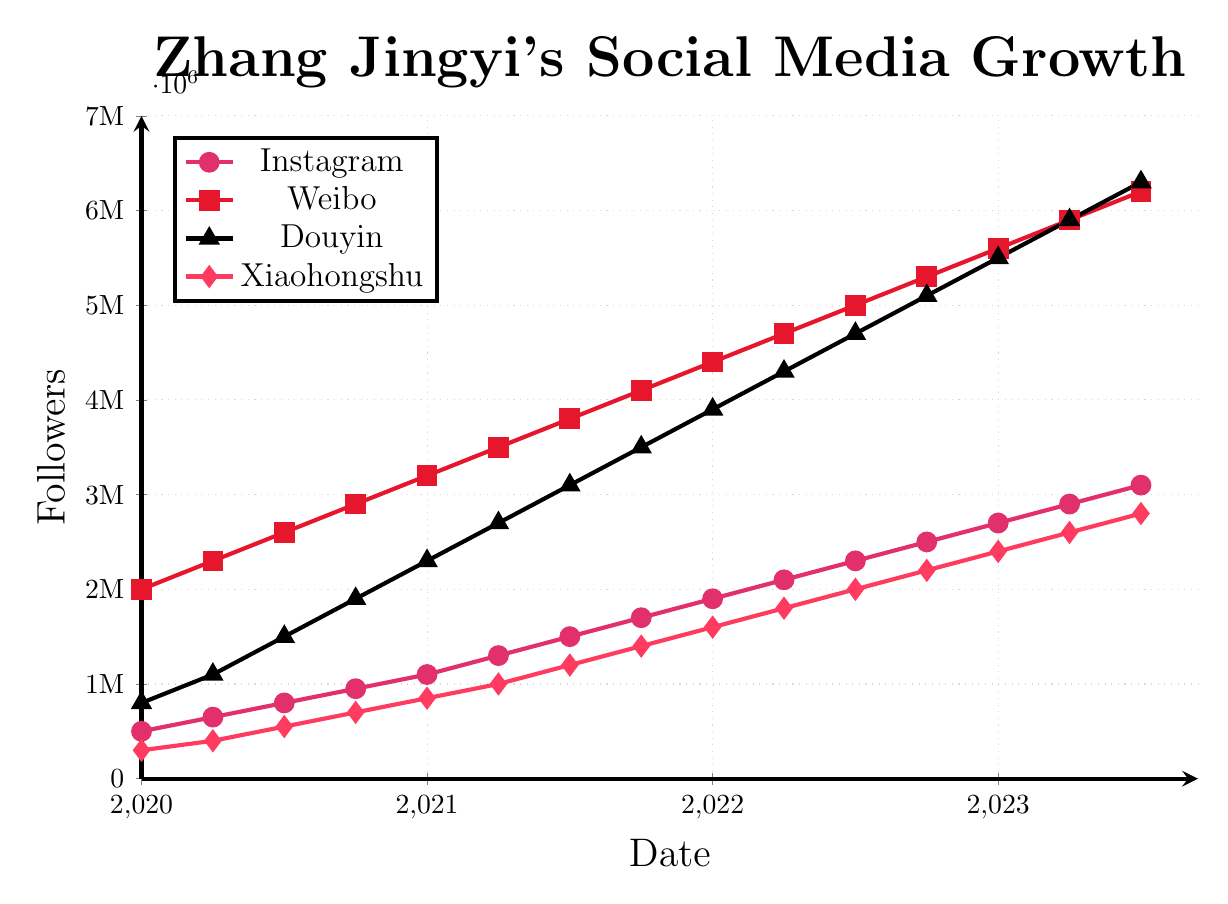Which social media platform had the highest follower count in July 2023? To determine the platform with the highest follower count in July 2023, observe the data points for each platform at the 2023.5 mark. Douyin has 6,300,000 followers, which is higher than the follower counts of Instagram, Weibo, and Xiaohongshu for that time.
Answer: Douyin How many followers did Zhang Jingyi gain on Weibo from January 2020 to July 2023? Calculate the difference between the follower count on Weibo in July 2023 and January 2020. The follower count on Weibo in July 2023 is 6,200,000, and in January 2020 it was 2,000,000. The difference is 6,200,000 - 2,000,000 = 4,200,000.
Answer: 4,200,000 Which platform showed the fastest growth from January 2020 to July 2023? Calculate the growth for each platform from January 2020 to July 2023 by subtracting the follower count at the start from the count at the end. Compare the growth values: Instagram (3,100,000 - 500,000 = 2,600,000), Weibo (6,200,000 - 2,000,000 = 4,200,000), Douyin (6,300,000 - 800,000 = 5,500,000), Xiaohongshu (2,800,000 - 300,000 = 2,500,000). Douyin has the highest increase.
Answer: Douyin What is the trend in follower growth for Xiaohongshu between mid-2020 and mid-2021? Look at the data points for Xiaohongshu between mid-2020 and mid-2021. In July 2020, it had 550,000 followers, and by July 2021, it had 1,200,000 followers. The followers steadily increased within this period, indicating a positive growth trend.
Answer: Positive trend On which platform did Zhang Jingyi have the most consistent growth? Consistent growth can be observed from platforms whose data points increase steadily without large fluctuations. By observing the plots, Weibo shows the most linear and steady upward growth pattern among all platforms.
Answer: Weibo What was the combined follower count across all platforms in January 2021? Add the follower counts for all platforms in January 2021: Instagram (1,100,000), Weibo (3,200,000), Douyin (2,300,000), Xiaohongshu (850,000). The total is 1,100,000 + 3,200,000 + 2,300,000 + 850,000 = 7,450,000.
Answer: 7,450,000 Which platform had the smallest follower base in the beginning and how much did it grow by July 2023? Identify the smallest follower base in January 2020; Xiaohongshu had 300,000 followers. In July 2023, Xiaohongshu had 2,800,000 followers. The growth is 2,800,000 - 300,000 = 2,500,000.
Answer: Xiaohongshu grew by 2,500,000 Looking at 2021 alone, which platform experienced the greatest growth in followers? To find the greatest growth in 2021, compare the follower counts from January 2021 to January 2022 for each platform: Instagram (1,100,000 to 1,900,000), Weibo (3,200,000 to 4,400,000), Douyin (2,300,000 to 3,900,000), Xiaohongshu (850,000 to 1,600,000). Douyin has the highest growth, increasing by 1,600,000 followers.
Answer: Douyin In which quarter did Zhang Jingyi's Weibo followers cross the 5 million mark? Locate the quarter where Weibo followers surpassed 5 million. From the plot, the follower count crossed 5 million between April 2022 and July 2022. Hence, it crossed the mark in Q2 2022.
Answer: Q2 2022 